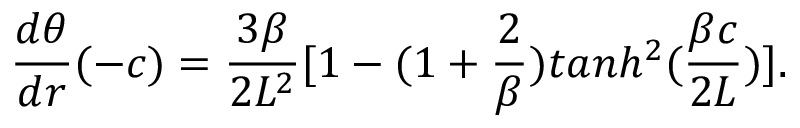<formula> <loc_0><loc_0><loc_500><loc_500>{ \frac { d \theta } { d r } } ( - c ) = { \frac { 3 \beta } { 2 L ^ { 2 } } } [ 1 - ( 1 + { \frac { 2 } { \beta } } ) t a n h ^ { 2 } ( { \frac { \beta c } { 2 L } } ) ] .</formula> 